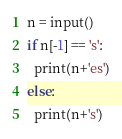<code> <loc_0><loc_0><loc_500><loc_500><_Python_>n = input()
if n[-1] == 's':
  print(n+'es')
else:
  print(n+'s')</code> 